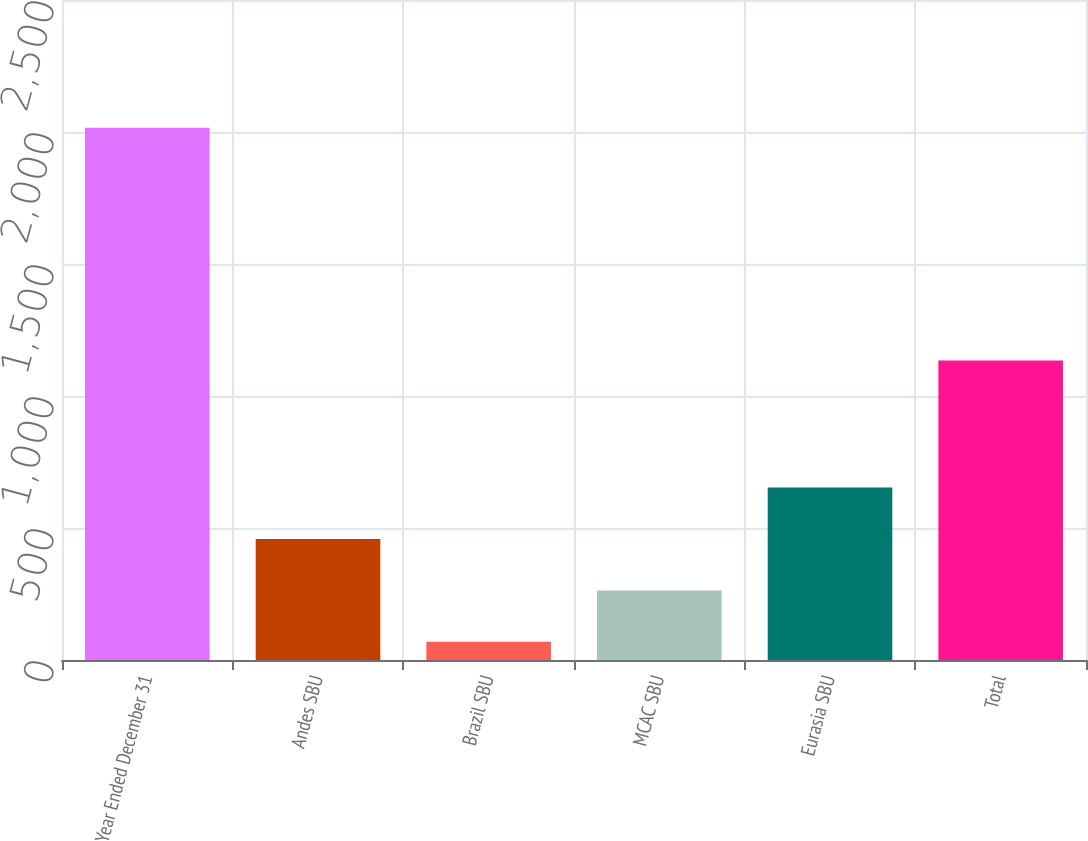Convert chart. <chart><loc_0><loc_0><loc_500><loc_500><bar_chart><fcel>Year Ended December 31<fcel>Andes SBU<fcel>Brazil SBU<fcel>MCAC SBU<fcel>Eurasia SBU<fcel>Total<nl><fcel>2016<fcel>458.4<fcel>69<fcel>263.7<fcel>653.1<fcel>1134<nl></chart> 